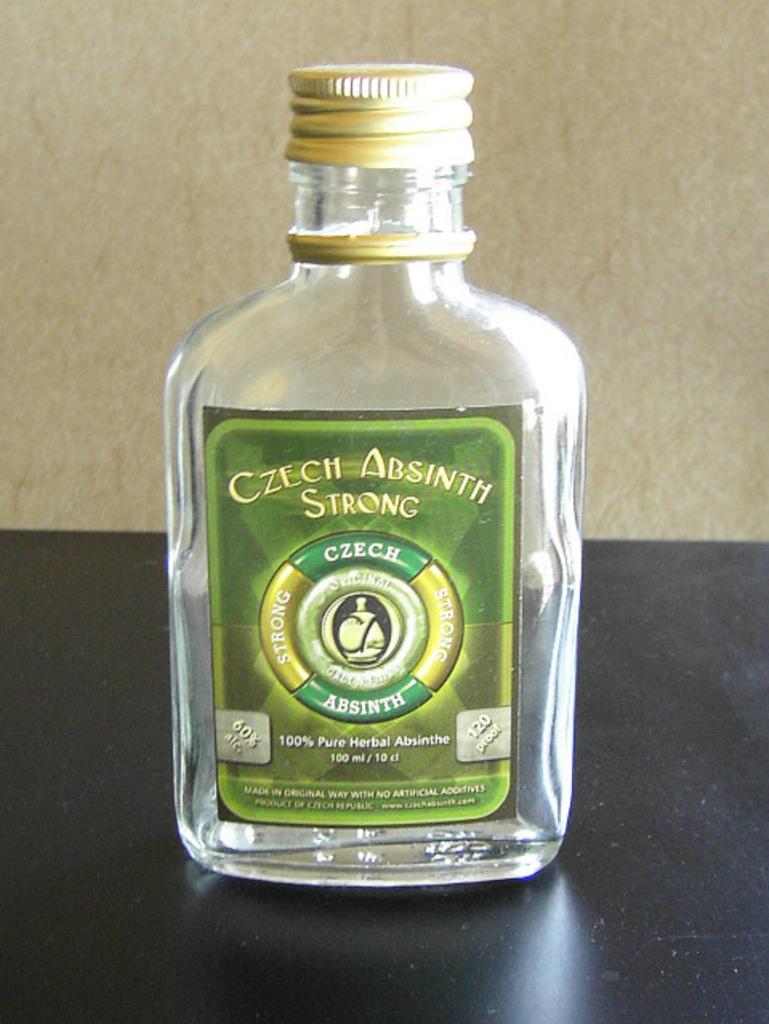Is this absinth?
Your response must be concise. Yes. What type of alcohol is in the bottle?
Make the answer very short. Absinth. 